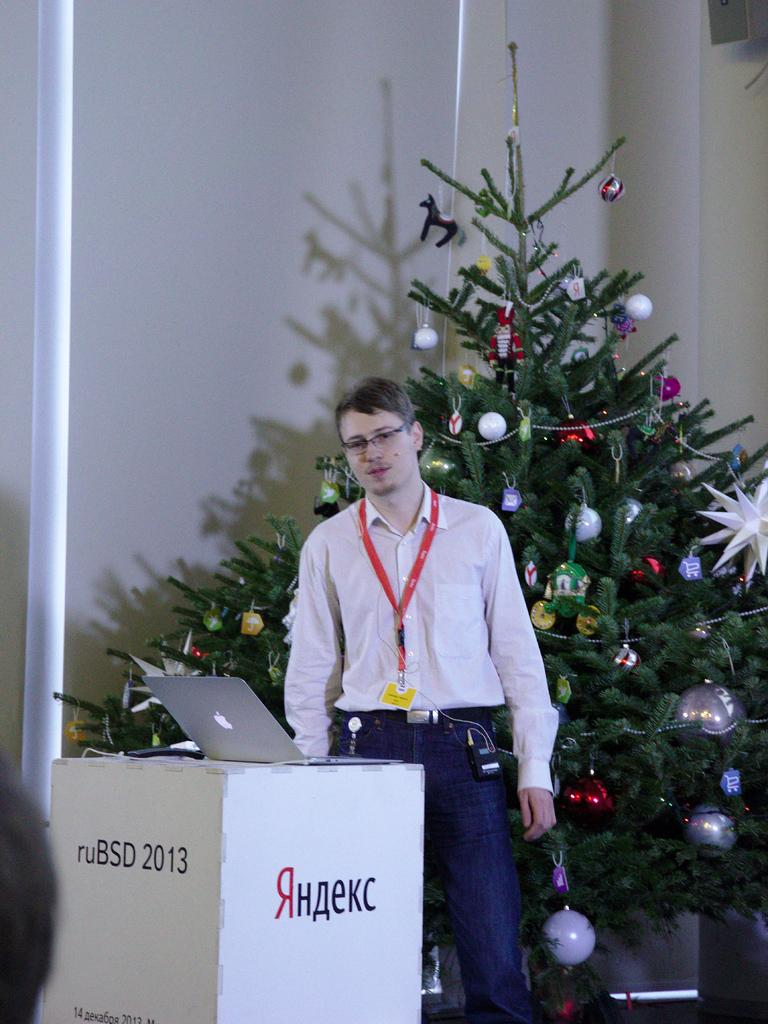<image>
Present a compact description of the photo's key features. A man stands behind a podium with the year 2013 on the front. 